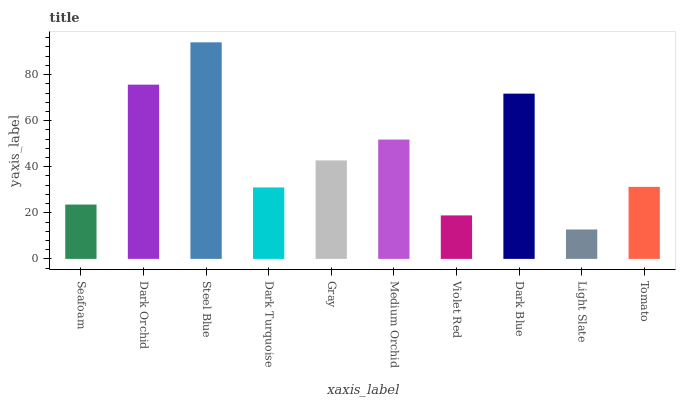Is Dark Orchid the minimum?
Answer yes or no. No. Is Dark Orchid the maximum?
Answer yes or no. No. Is Dark Orchid greater than Seafoam?
Answer yes or no. Yes. Is Seafoam less than Dark Orchid?
Answer yes or no. Yes. Is Seafoam greater than Dark Orchid?
Answer yes or no. No. Is Dark Orchid less than Seafoam?
Answer yes or no. No. Is Gray the high median?
Answer yes or no. Yes. Is Tomato the low median?
Answer yes or no. Yes. Is Seafoam the high median?
Answer yes or no. No. Is Gray the low median?
Answer yes or no. No. 